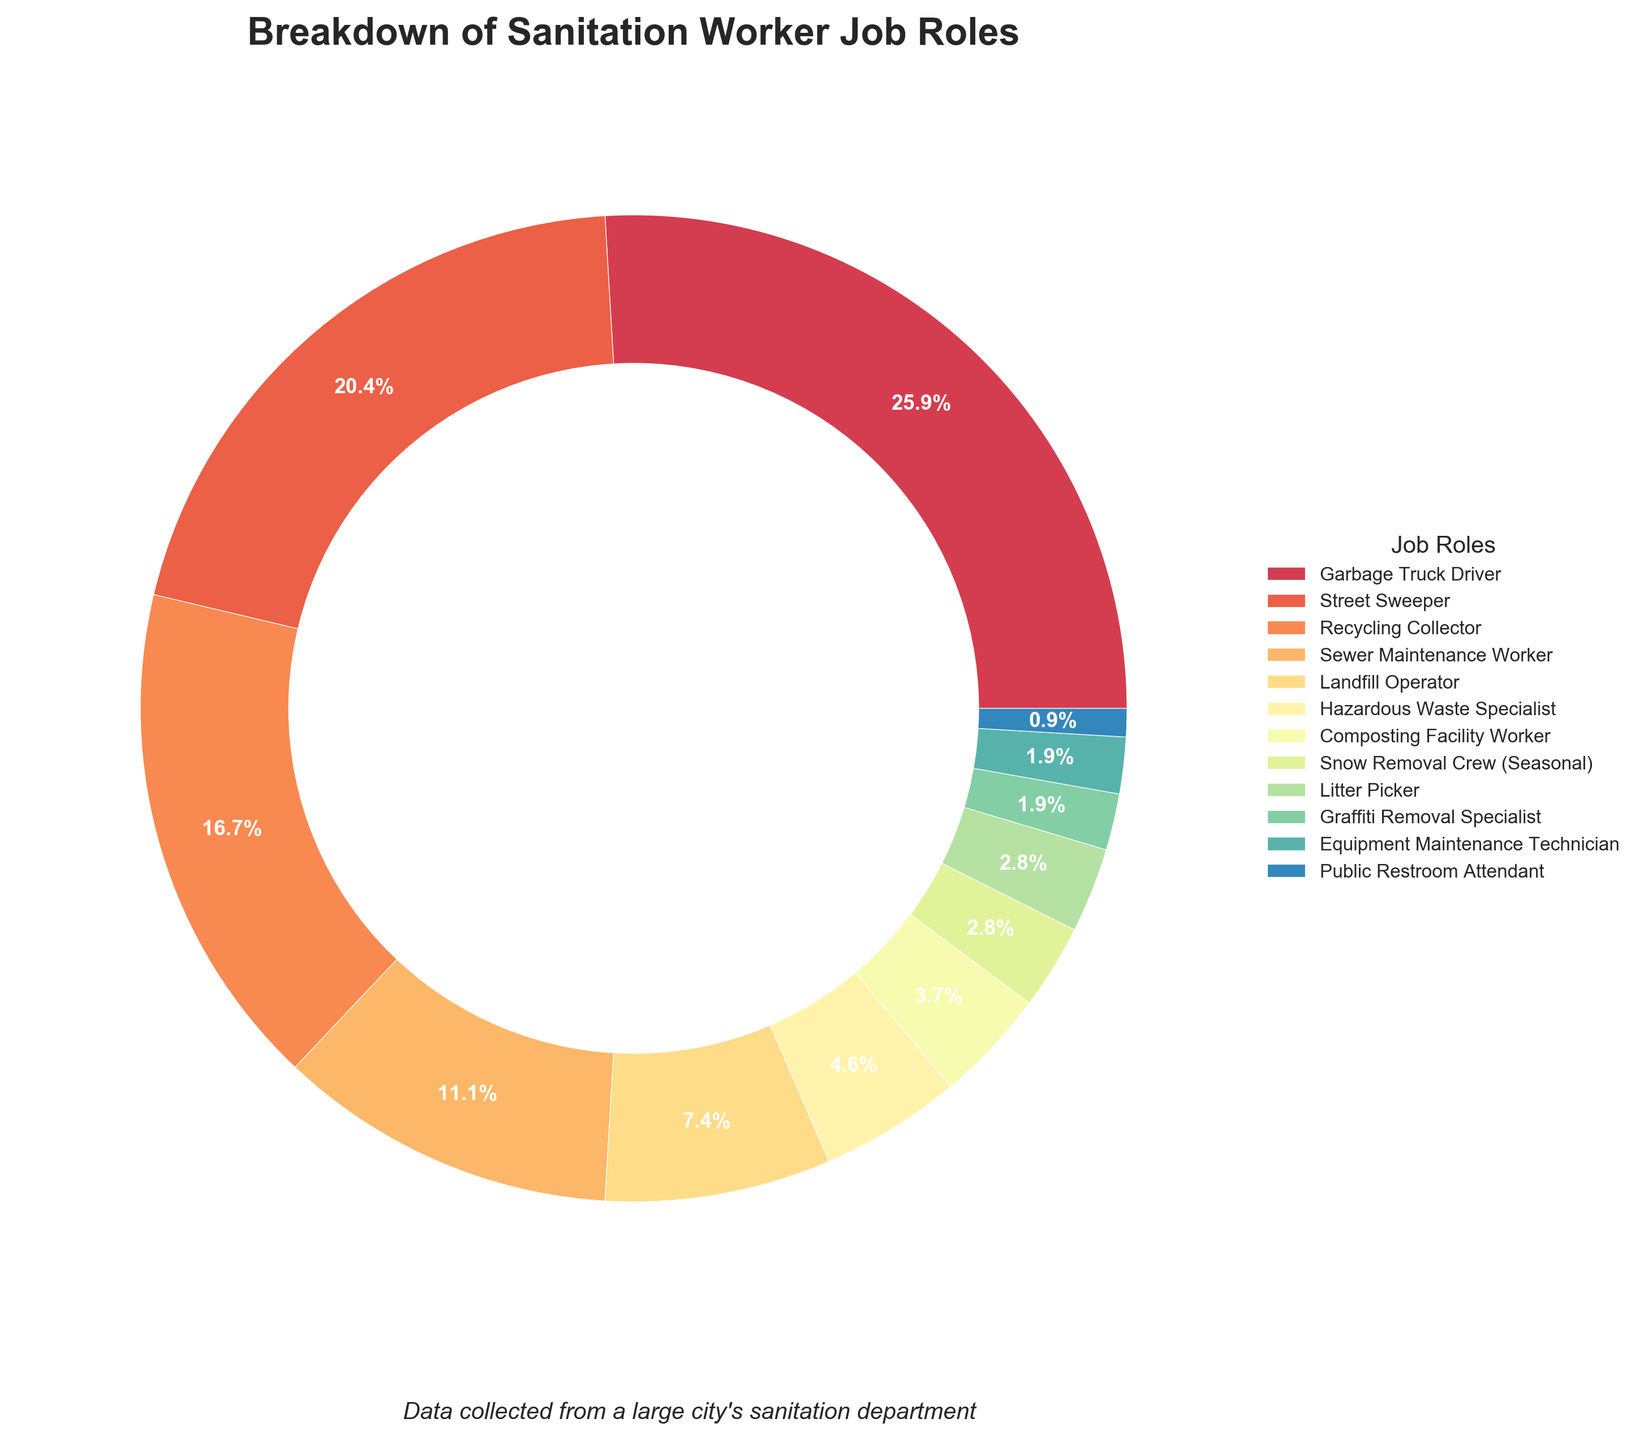What percentage of sanitation workers are responsible for recycling collection? The recycling collector section of the pie chart indicates that this role accounts for 18% of the total
Answer: 18% Which job role has the smallest percentage of workers, and what is that percentage? By looking at the smallest segment of the pie chart, the public restroom attendant role is the least, accounting for 1% of the total
Answer: Public Restroom Attendant, 1% How much larger is the percentage of garbage truck drivers compared to street sweepers? Garbage truck drivers account for 28%, while street sweepers account for 22%. Subtract 22% from 28% to find the difference: 28% - 22% = 6%
Answer: 6% Which two job roles combined make up exactly 10% of the workforce? By evaluating the percentages, the hazardous waste specialist (5%) and composting facility worker (4%) do not total 10%. However, combining snow removal crew (3%) and litter picker (3%) equals 6%. Adding graffit removal specialist creates other roles. Hence, no exact 10% by combining two roles
Answer: None What is the combined percentage of sewer maintenance workers and landfill operators? Sewer maintenance workers account for 12%, and landfill operators account for 8%. Adding these together: 12% + 8% = 20%
Answer: 20% How does the percentage of litter pickers compare to that of graffiti removal specialists? Litter pickers account for 3% of the workforce, while graffiti removal specialists account for 2%. Therefore, litter pickers have a higher percentage by 1%
Answer: Litter pickers have 1% more Which roles together constitute a higher percentage: landfill operators and hazardous waste specialists or snow removal crew and litter pickers? Landfill operators (8%) plus hazardous waste specialists (5%) equal 13%. Snow removal crew (3%) plus litter pickers (3%) equal 6%. So, landfill operators and hazardous waste specialists have a higher combined percentage
Answer: Landfill operators and hazardous waste specialists Excluding seasonal roles, what is the average percentage of workers in each job role? First, exclude snow removal crew (3%). Then, sum up the percentages of the remaining roles (28+22+18+12+8+5+4+3+2+2+1 = 105). Let’s count the roles (11). The average is the total percentage divided by the number of roles: 105 / 11 ≈ 9.55%
Answer: 9.55% What is the median percentage value for all job roles? Arrange percentages in ascending order: 1, 2, 2, 3, 3, 4, 5, 8, 12, 18, 22, 28. Count of values is 12, so the median is the average of the 6th and 7th values: (4+5)/2 = 4.5%
Answer: 4.5% Identify all job roles that together make up less than 10% of the workforce. The segments with percentages less than 10% are: hazardous waste specialist (5%), composting facility worker (4%), snow removal crew (3%), litter picker (3%), graffiti removal specialist (2%), equipment maintenance technician (2%), public restroom attendant (1%)
Answer: Hazardous Waste Specialist, Composting Facility Worker, Snow Removal Crew, Litter Picker, Graffiti Removal Specialist, Equipment Maintenance Technician, Public Restroom Attendant 